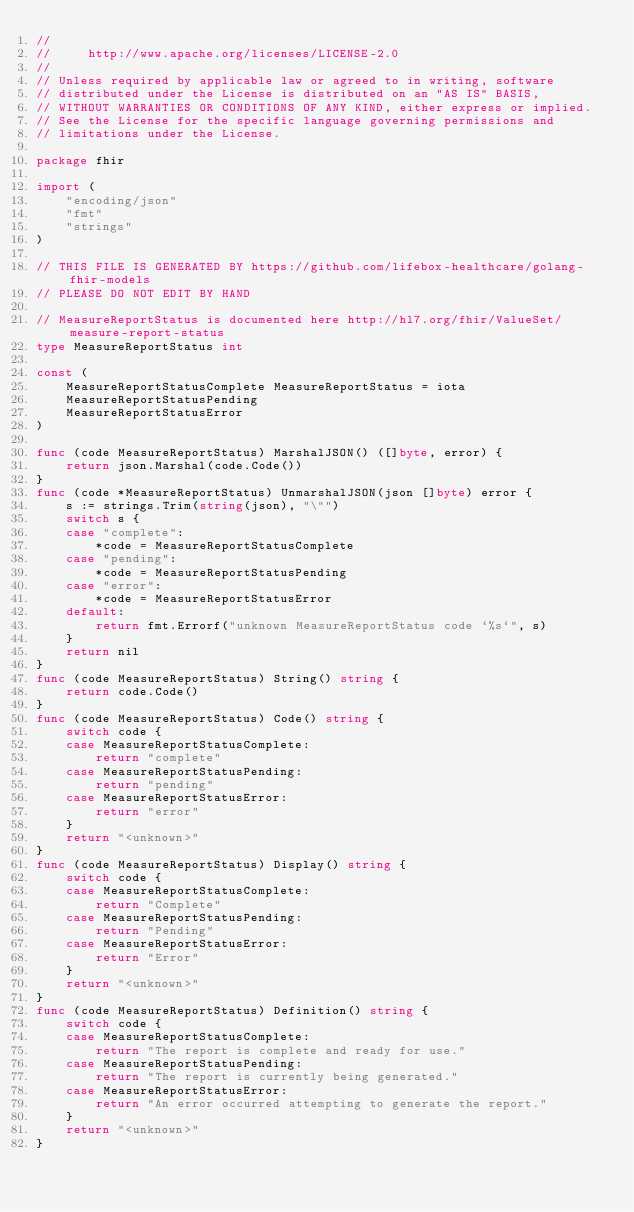<code> <loc_0><loc_0><loc_500><loc_500><_Go_>//
//     http://www.apache.org/licenses/LICENSE-2.0
//
// Unless required by applicable law or agreed to in writing, software
// distributed under the License is distributed on an "AS IS" BASIS,
// WITHOUT WARRANTIES OR CONDITIONS OF ANY KIND, either express or implied.
// See the License for the specific language governing permissions and
// limitations under the License.

package fhir

import (
	"encoding/json"
	"fmt"
	"strings"
)

// THIS FILE IS GENERATED BY https://github.com/lifebox-healthcare/golang-fhir-models
// PLEASE DO NOT EDIT BY HAND

// MeasureReportStatus is documented here http://hl7.org/fhir/ValueSet/measure-report-status
type MeasureReportStatus int

const (
	MeasureReportStatusComplete MeasureReportStatus = iota
	MeasureReportStatusPending
	MeasureReportStatusError
)

func (code MeasureReportStatus) MarshalJSON() ([]byte, error) {
	return json.Marshal(code.Code())
}
func (code *MeasureReportStatus) UnmarshalJSON(json []byte) error {
	s := strings.Trim(string(json), "\"")
	switch s {
	case "complete":
		*code = MeasureReportStatusComplete
	case "pending":
		*code = MeasureReportStatusPending
	case "error":
		*code = MeasureReportStatusError
	default:
		return fmt.Errorf("unknown MeasureReportStatus code `%s`", s)
	}
	return nil
}
func (code MeasureReportStatus) String() string {
	return code.Code()
}
func (code MeasureReportStatus) Code() string {
	switch code {
	case MeasureReportStatusComplete:
		return "complete"
	case MeasureReportStatusPending:
		return "pending"
	case MeasureReportStatusError:
		return "error"
	}
	return "<unknown>"
}
func (code MeasureReportStatus) Display() string {
	switch code {
	case MeasureReportStatusComplete:
		return "Complete"
	case MeasureReportStatusPending:
		return "Pending"
	case MeasureReportStatusError:
		return "Error"
	}
	return "<unknown>"
}
func (code MeasureReportStatus) Definition() string {
	switch code {
	case MeasureReportStatusComplete:
		return "The report is complete and ready for use."
	case MeasureReportStatusPending:
		return "The report is currently being generated."
	case MeasureReportStatusError:
		return "An error occurred attempting to generate the report."
	}
	return "<unknown>"
}
</code> 